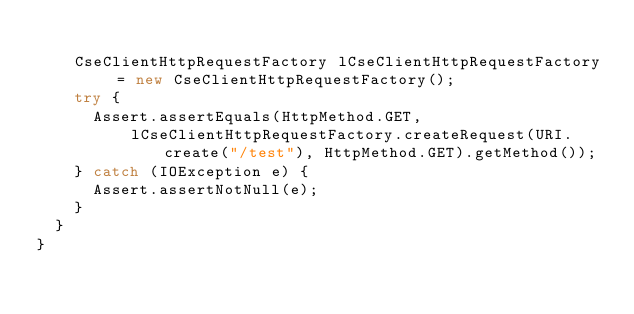<code> <loc_0><loc_0><loc_500><loc_500><_Java_>
    CseClientHttpRequestFactory lCseClientHttpRequestFactory = new CseClientHttpRequestFactory();
    try {
      Assert.assertEquals(HttpMethod.GET,
          lCseClientHttpRequestFactory.createRequest(URI.create("/test"), HttpMethod.GET).getMethod());
    } catch (IOException e) {
      Assert.assertNotNull(e);
    }
  }
}
</code> 